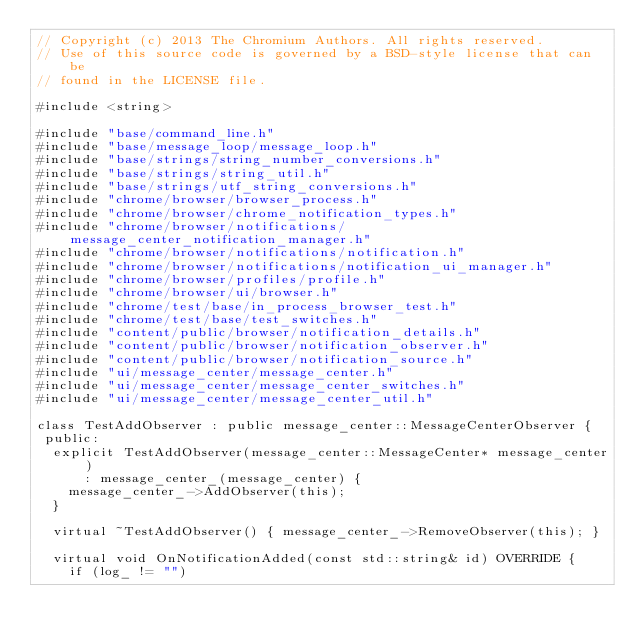<code> <loc_0><loc_0><loc_500><loc_500><_C++_>// Copyright (c) 2013 The Chromium Authors. All rights reserved.
// Use of this source code is governed by a BSD-style license that can be
// found in the LICENSE file.

#include <string>

#include "base/command_line.h"
#include "base/message_loop/message_loop.h"
#include "base/strings/string_number_conversions.h"
#include "base/strings/string_util.h"
#include "base/strings/utf_string_conversions.h"
#include "chrome/browser/browser_process.h"
#include "chrome/browser/chrome_notification_types.h"
#include "chrome/browser/notifications/message_center_notification_manager.h"
#include "chrome/browser/notifications/notification.h"
#include "chrome/browser/notifications/notification_ui_manager.h"
#include "chrome/browser/profiles/profile.h"
#include "chrome/browser/ui/browser.h"
#include "chrome/test/base/in_process_browser_test.h"
#include "chrome/test/base/test_switches.h"
#include "content/public/browser/notification_details.h"
#include "content/public/browser/notification_observer.h"
#include "content/public/browser/notification_source.h"
#include "ui/message_center/message_center.h"
#include "ui/message_center/message_center_switches.h"
#include "ui/message_center/message_center_util.h"

class TestAddObserver : public message_center::MessageCenterObserver {
 public:
  explicit TestAddObserver(message_center::MessageCenter* message_center)
      : message_center_(message_center) {
    message_center_->AddObserver(this);
  }

  virtual ~TestAddObserver() { message_center_->RemoveObserver(this); }

  virtual void OnNotificationAdded(const std::string& id) OVERRIDE {
    if (log_ != "")</code> 